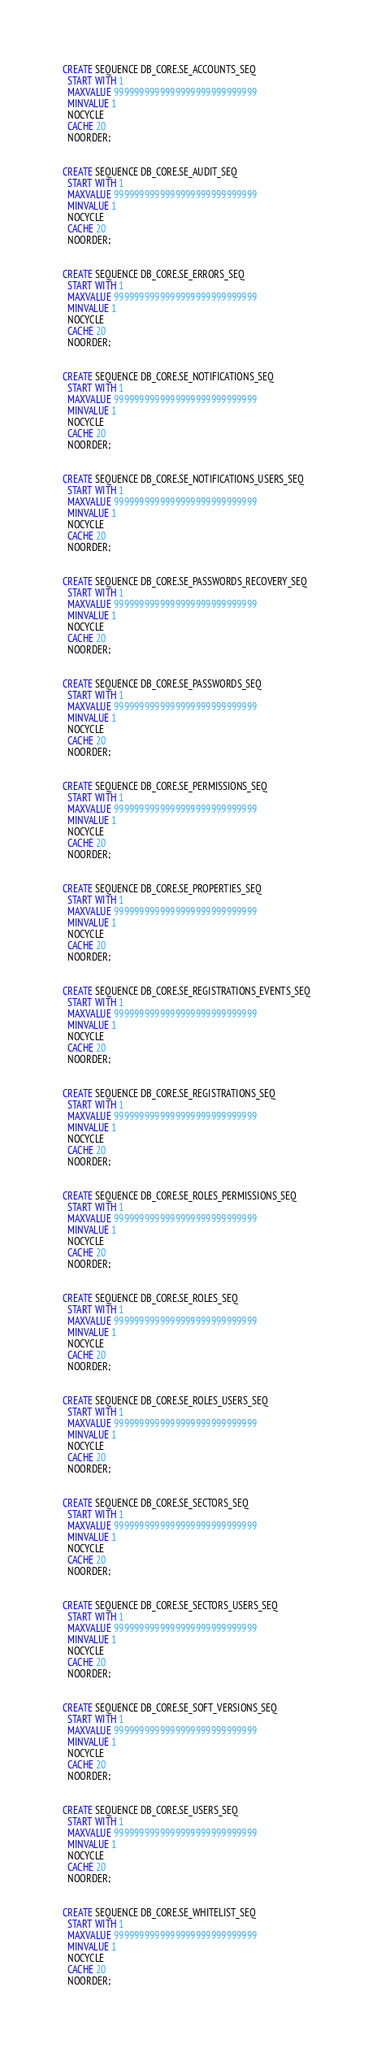<code> <loc_0><loc_0><loc_500><loc_500><_SQL_>CREATE SEQUENCE DB_CORE.SE_ACCOUNTS_SEQ
  START WITH 1
  MAXVALUE 9999999999999999999999999999
  MINVALUE 1
  NOCYCLE
  CACHE 20
  NOORDER;


CREATE SEQUENCE DB_CORE.SE_AUDIT_SEQ
  START WITH 1
  MAXVALUE 9999999999999999999999999999
  MINVALUE 1
  NOCYCLE
  CACHE 20
  NOORDER;


CREATE SEQUENCE DB_CORE.SE_ERRORS_SEQ
  START WITH 1
  MAXVALUE 9999999999999999999999999999
  MINVALUE 1
  NOCYCLE
  CACHE 20
  NOORDER;


CREATE SEQUENCE DB_CORE.SE_NOTIFICATIONS_SEQ
  START WITH 1
  MAXVALUE 9999999999999999999999999999
  MINVALUE 1
  NOCYCLE
  CACHE 20
  NOORDER;


CREATE SEQUENCE DB_CORE.SE_NOTIFICATIONS_USERS_SEQ
  START WITH 1
  MAXVALUE 9999999999999999999999999999
  MINVALUE 1
  NOCYCLE
  CACHE 20
  NOORDER;


CREATE SEQUENCE DB_CORE.SE_PASSWORDS_RECOVERY_SEQ
  START WITH 1
  MAXVALUE 9999999999999999999999999999
  MINVALUE 1
  NOCYCLE
  CACHE 20
  NOORDER;


CREATE SEQUENCE DB_CORE.SE_PASSWORDS_SEQ
  START WITH 1
  MAXVALUE 9999999999999999999999999999
  MINVALUE 1
  NOCYCLE
  CACHE 20
  NOORDER;


CREATE SEQUENCE DB_CORE.SE_PERMISSIONS_SEQ
  START WITH 1
  MAXVALUE 9999999999999999999999999999
  MINVALUE 1
  NOCYCLE
  CACHE 20
  NOORDER;


CREATE SEQUENCE DB_CORE.SE_PROPERTIES_SEQ
  START WITH 1
  MAXVALUE 9999999999999999999999999999
  MINVALUE 1
  NOCYCLE
  CACHE 20
  NOORDER;


CREATE SEQUENCE DB_CORE.SE_REGISTRATIONS_EVENTS_SEQ
  START WITH 1
  MAXVALUE 9999999999999999999999999999
  MINVALUE 1
  NOCYCLE
  CACHE 20
  NOORDER;


CREATE SEQUENCE DB_CORE.SE_REGISTRATIONS_SEQ
  START WITH 1
  MAXVALUE 9999999999999999999999999999
  MINVALUE 1
  NOCYCLE
  CACHE 20
  NOORDER;


CREATE SEQUENCE DB_CORE.SE_ROLES_PERMISSIONS_SEQ
  START WITH 1
  MAXVALUE 9999999999999999999999999999
  MINVALUE 1
  NOCYCLE
  CACHE 20
  NOORDER;


CREATE SEQUENCE DB_CORE.SE_ROLES_SEQ
  START WITH 1
  MAXVALUE 9999999999999999999999999999
  MINVALUE 1
  NOCYCLE
  CACHE 20
  NOORDER;


CREATE SEQUENCE DB_CORE.SE_ROLES_USERS_SEQ
  START WITH 1
  MAXVALUE 9999999999999999999999999999
  MINVALUE 1
  NOCYCLE
  CACHE 20
  NOORDER;


CREATE SEQUENCE DB_CORE.SE_SECTORS_SEQ
  START WITH 1
  MAXVALUE 9999999999999999999999999999
  MINVALUE 1
  NOCYCLE
  CACHE 20
  NOORDER;


CREATE SEQUENCE DB_CORE.SE_SECTORS_USERS_SEQ
  START WITH 1
  MAXVALUE 9999999999999999999999999999
  MINVALUE 1
  NOCYCLE
  CACHE 20
  NOORDER;


CREATE SEQUENCE DB_CORE.SE_SOFT_VERSIONS_SEQ
  START WITH 1
  MAXVALUE 9999999999999999999999999999
  MINVALUE 1
  NOCYCLE
  CACHE 20
  NOORDER;


CREATE SEQUENCE DB_CORE.SE_USERS_SEQ
  START WITH 1
  MAXVALUE 9999999999999999999999999999
  MINVALUE 1
  NOCYCLE
  CACHE 20
  NOORDER;


CREATE SEQUENCE DB_CORE.SE_WHITELIST_SEQ
  START WITH 1
  MAXVALUE 9999999999999999999999999999
  MINVALUE 1
  NOCYCLE
  CACHE 20
  NOORDER;</code> 